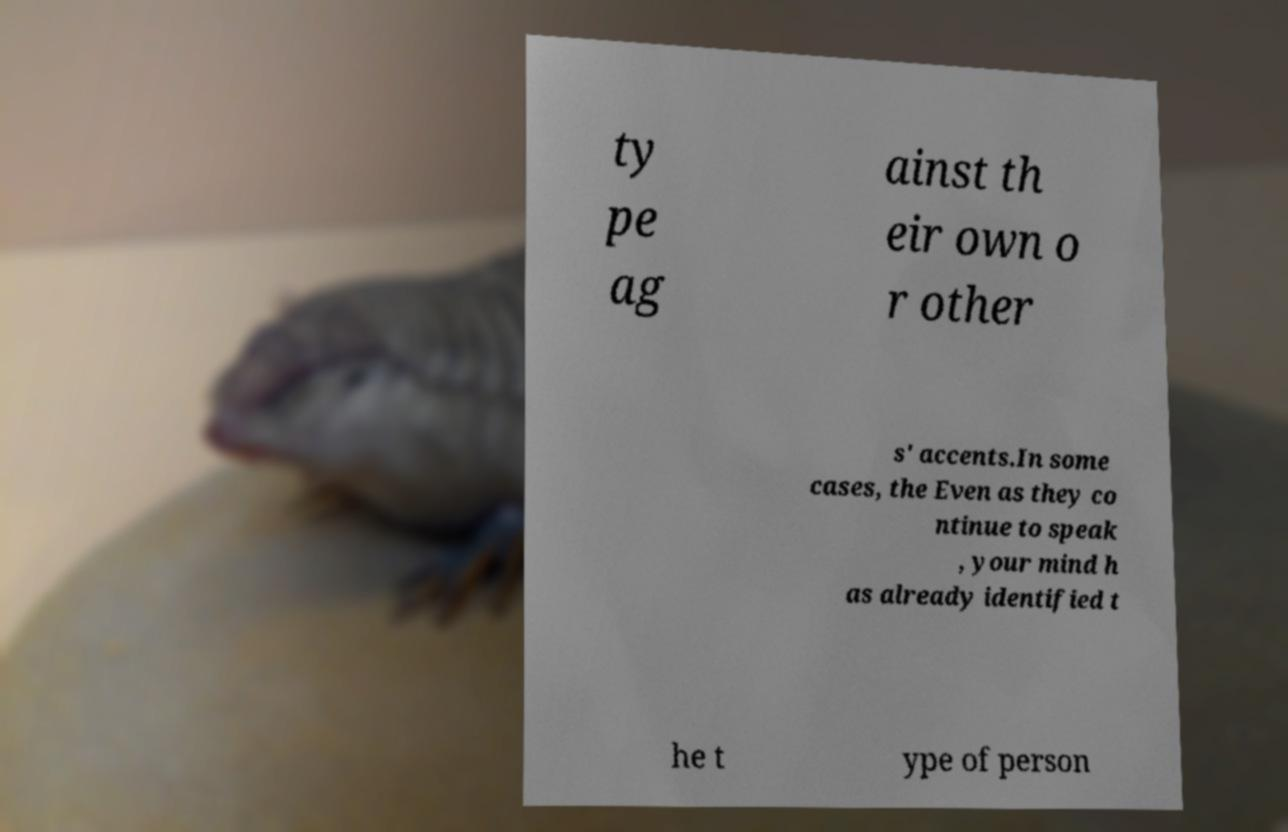I need the written content from this picture converted into text. Can you do that? ty pe ag ainst th eir own o r other s' accents.In some cases, the Even as they co ntinue to speak , your mind h as already identified t he t ype of person 